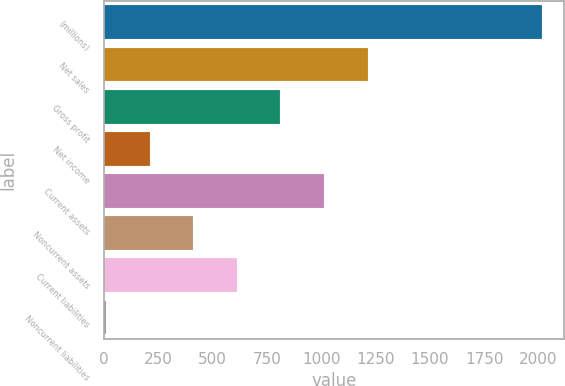Convert chart to OTSL. <chart><loc_0><loc_0><loc_500><loc_500><bar_chart><fcel>(millions)<fcel>Net sales<fcel>Gross profit<fcel>Net income<fcel>Current assets<fcel>Noncurrent assets<fcel>Current liabilities<fcel>Noncurrent liabilities<nl><fcel>2016<fcel>1213.24<fcel>811.86<fcel>209.79<fcel>1012.55<fcel>410.48<fcel>611.17<fcel>9.1<nl></chart> 